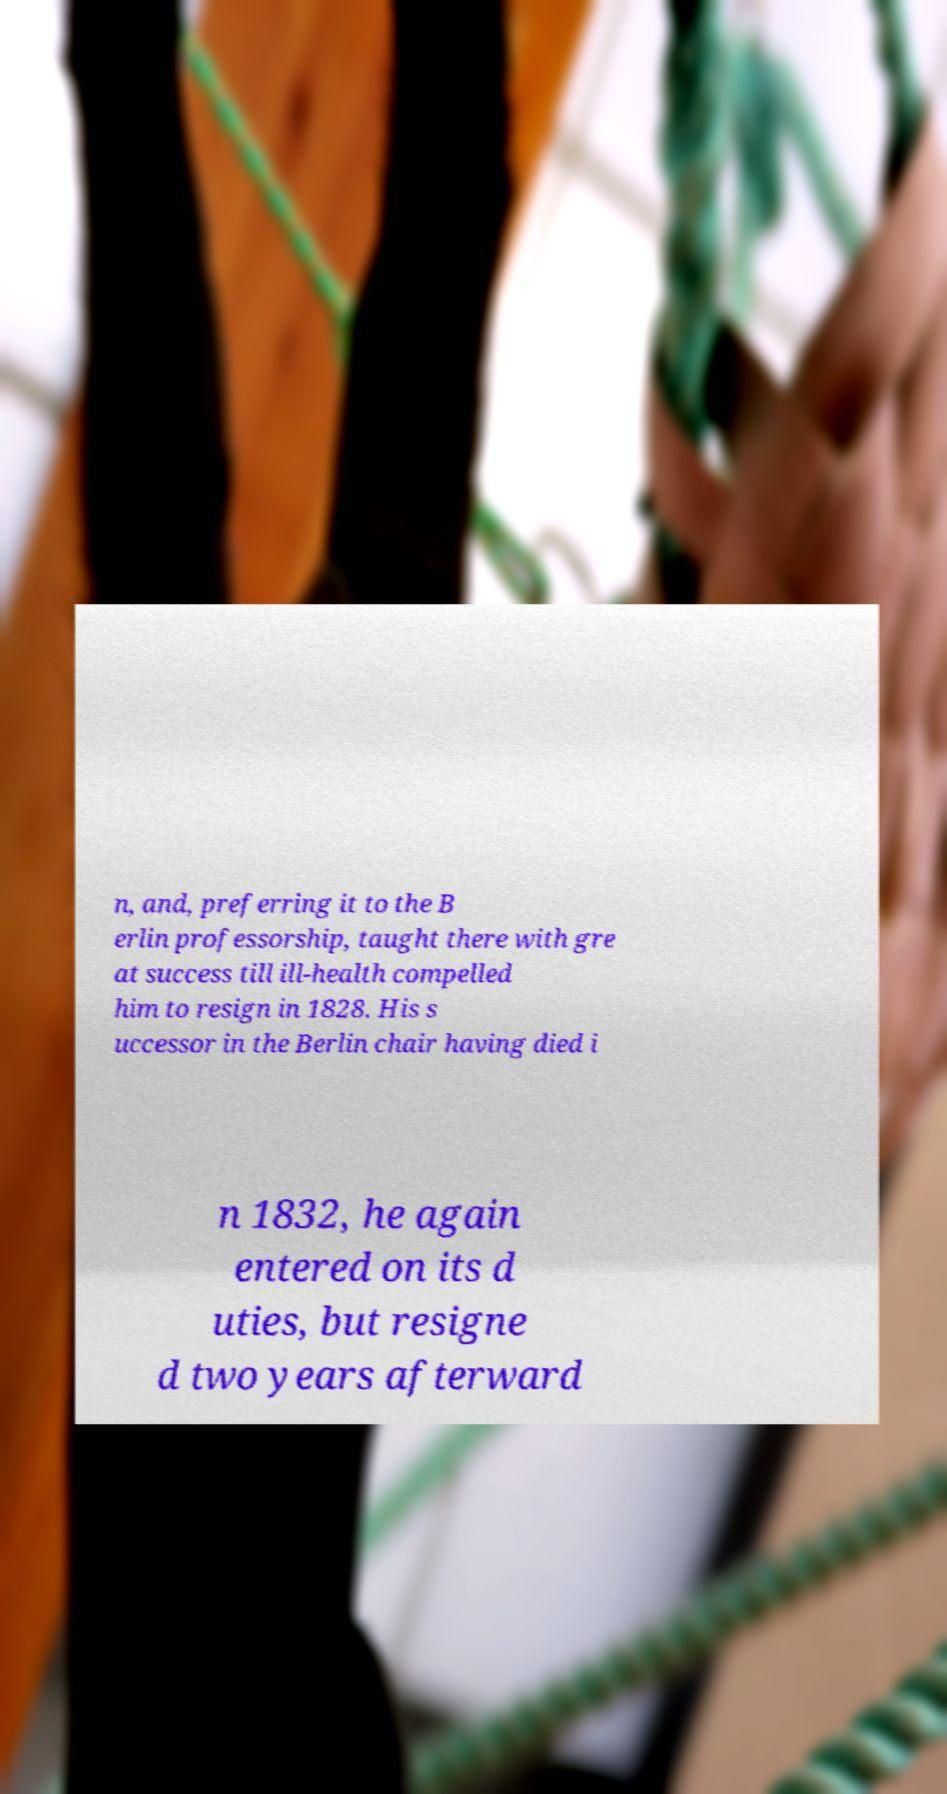Could you assist in decoding the text presented in this image and type it out clearly? n, and, preferring it to the B erlin professorship, taught there with gre at success till ill-health compelled him to resign in 1828. His s uccessor in the Berlin chair having died i n 1832, he again entered on its d uties, but resigne d two years afterward 